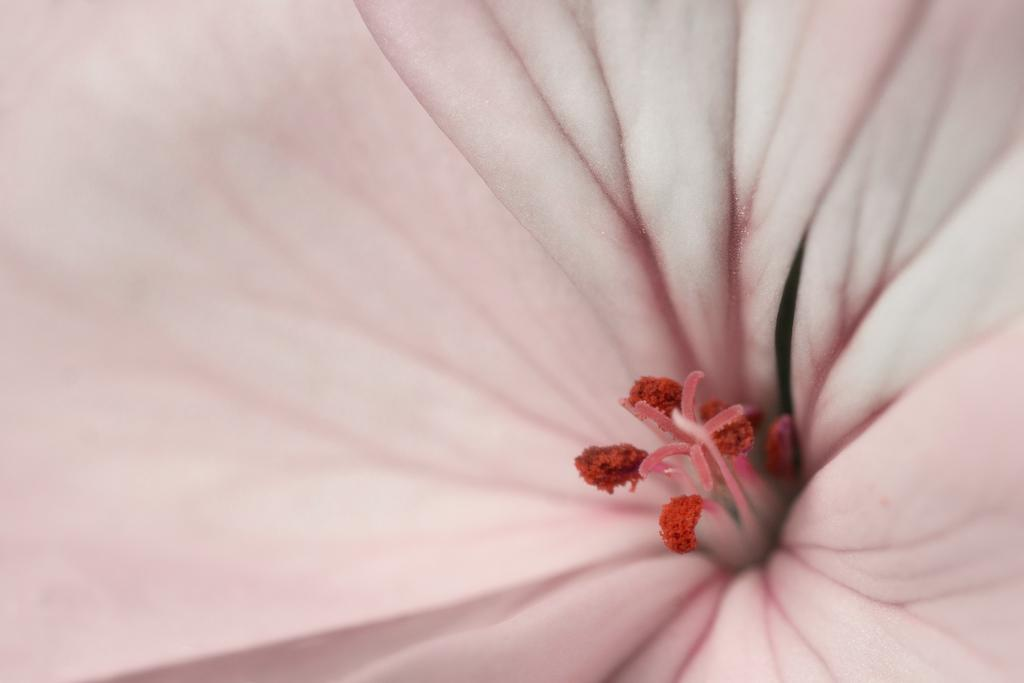What is the main subject of the picture? The main subject of the picture is a flower. Can you describe the colors of the flower? The flower has pink and red colors. What type of connection can be seen between the flower and the ground in the image? There is no connection between the flower and the ground depicted in the image, as it only shows the flower itself. 